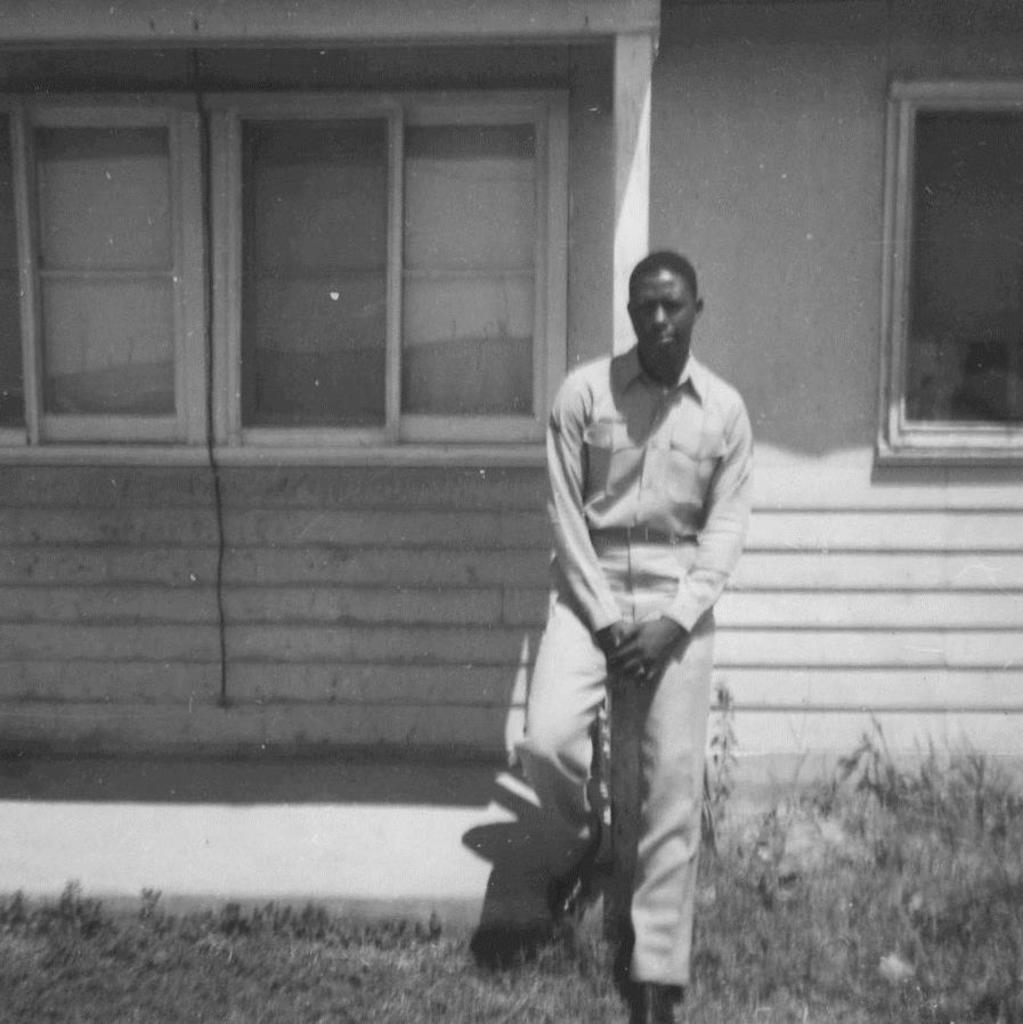Please provide a concise description of this image. In this image there is a person standing, and there is grass ,plants , house with windows. 